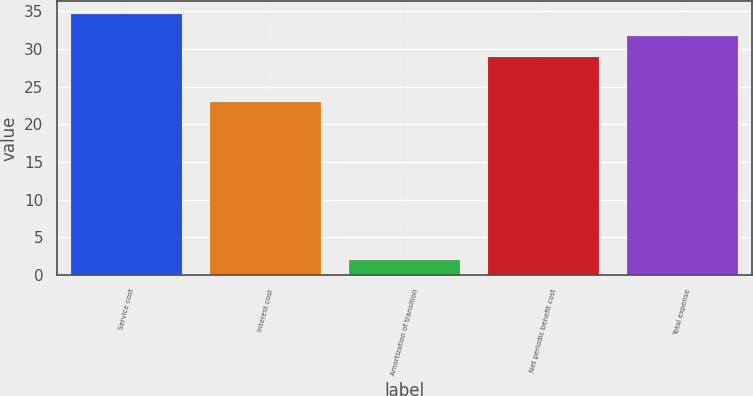<chart> <loc_0><loc_0><loc_500><loc_500><bar_chart><fcel>Service cost<fcel>Interest cost<fcel>Amortization of transition<fcel>Net periodic benefit cost<fcel>Total expense<nl><fcel>34.6<fcel>23<fcel>2<fcel>29<fcel>31.8<nl></chart> 